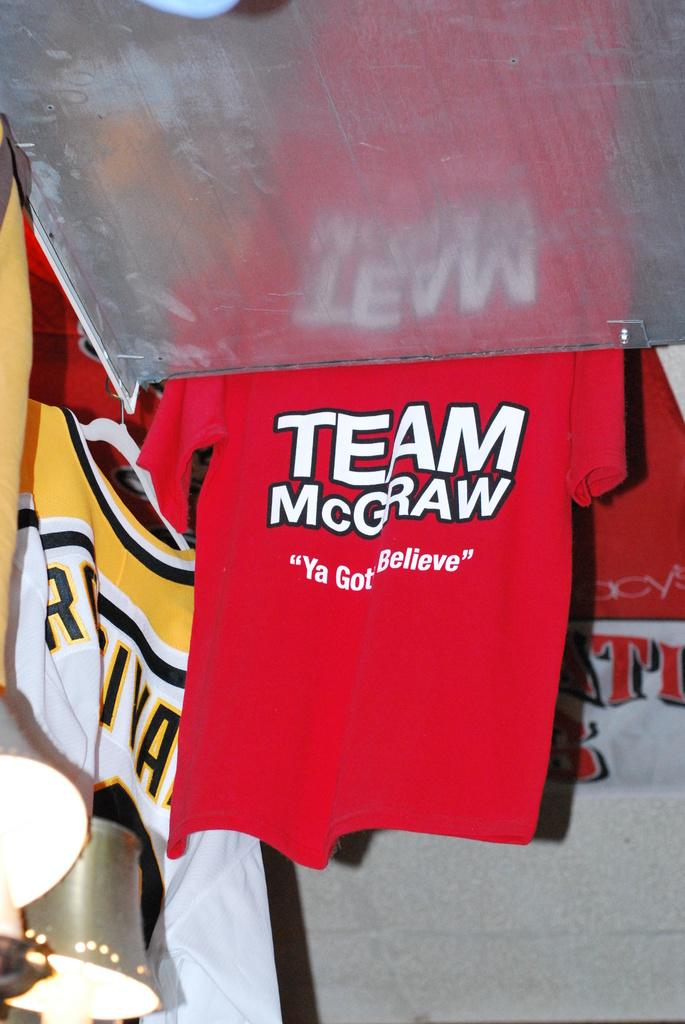<image>
Write a terse but informative summary of the picture. Red and white team McGraw shirt hangs on the wall with other shirts. 